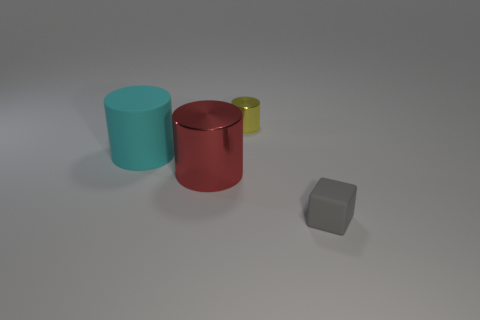What number of tiny objects are either cyan metallic cylinders or cyan cylinders?
Offer a terse response. 0. What is the size of the yellow metallic thing that is the same shape as the big cyan object?
Ensure brevity in your answer.  Small. The large red object is what shape?
Your answer should be very brief. Cylinder. Are the gray object and the cylinder on the left side of the big red metallic cylinder made of the same material?
Your response must be concise. Yes. What number of metal things are either cyan objects or yellow cylinders?
Give a very brief answer. 1. There is a matte thing in front of the large metal cylinder; what size is it?
Keep it short and to the point. Small. What size is the block that is the same material as the cyan thing?
Your answer should be compact. Small. Are any gray rubber cubes visible?
Your answer should be very brief. Yes. Does the small yellow metal thing have the same shape as the object that is in front of the large red shiny thing?
Provide a succinct answer. No. There is a big object to the left of the large cylinder that is in front of the matte thing that is behind the small matte cube; what is its color?
Keep it short and to the point. Cyan. 